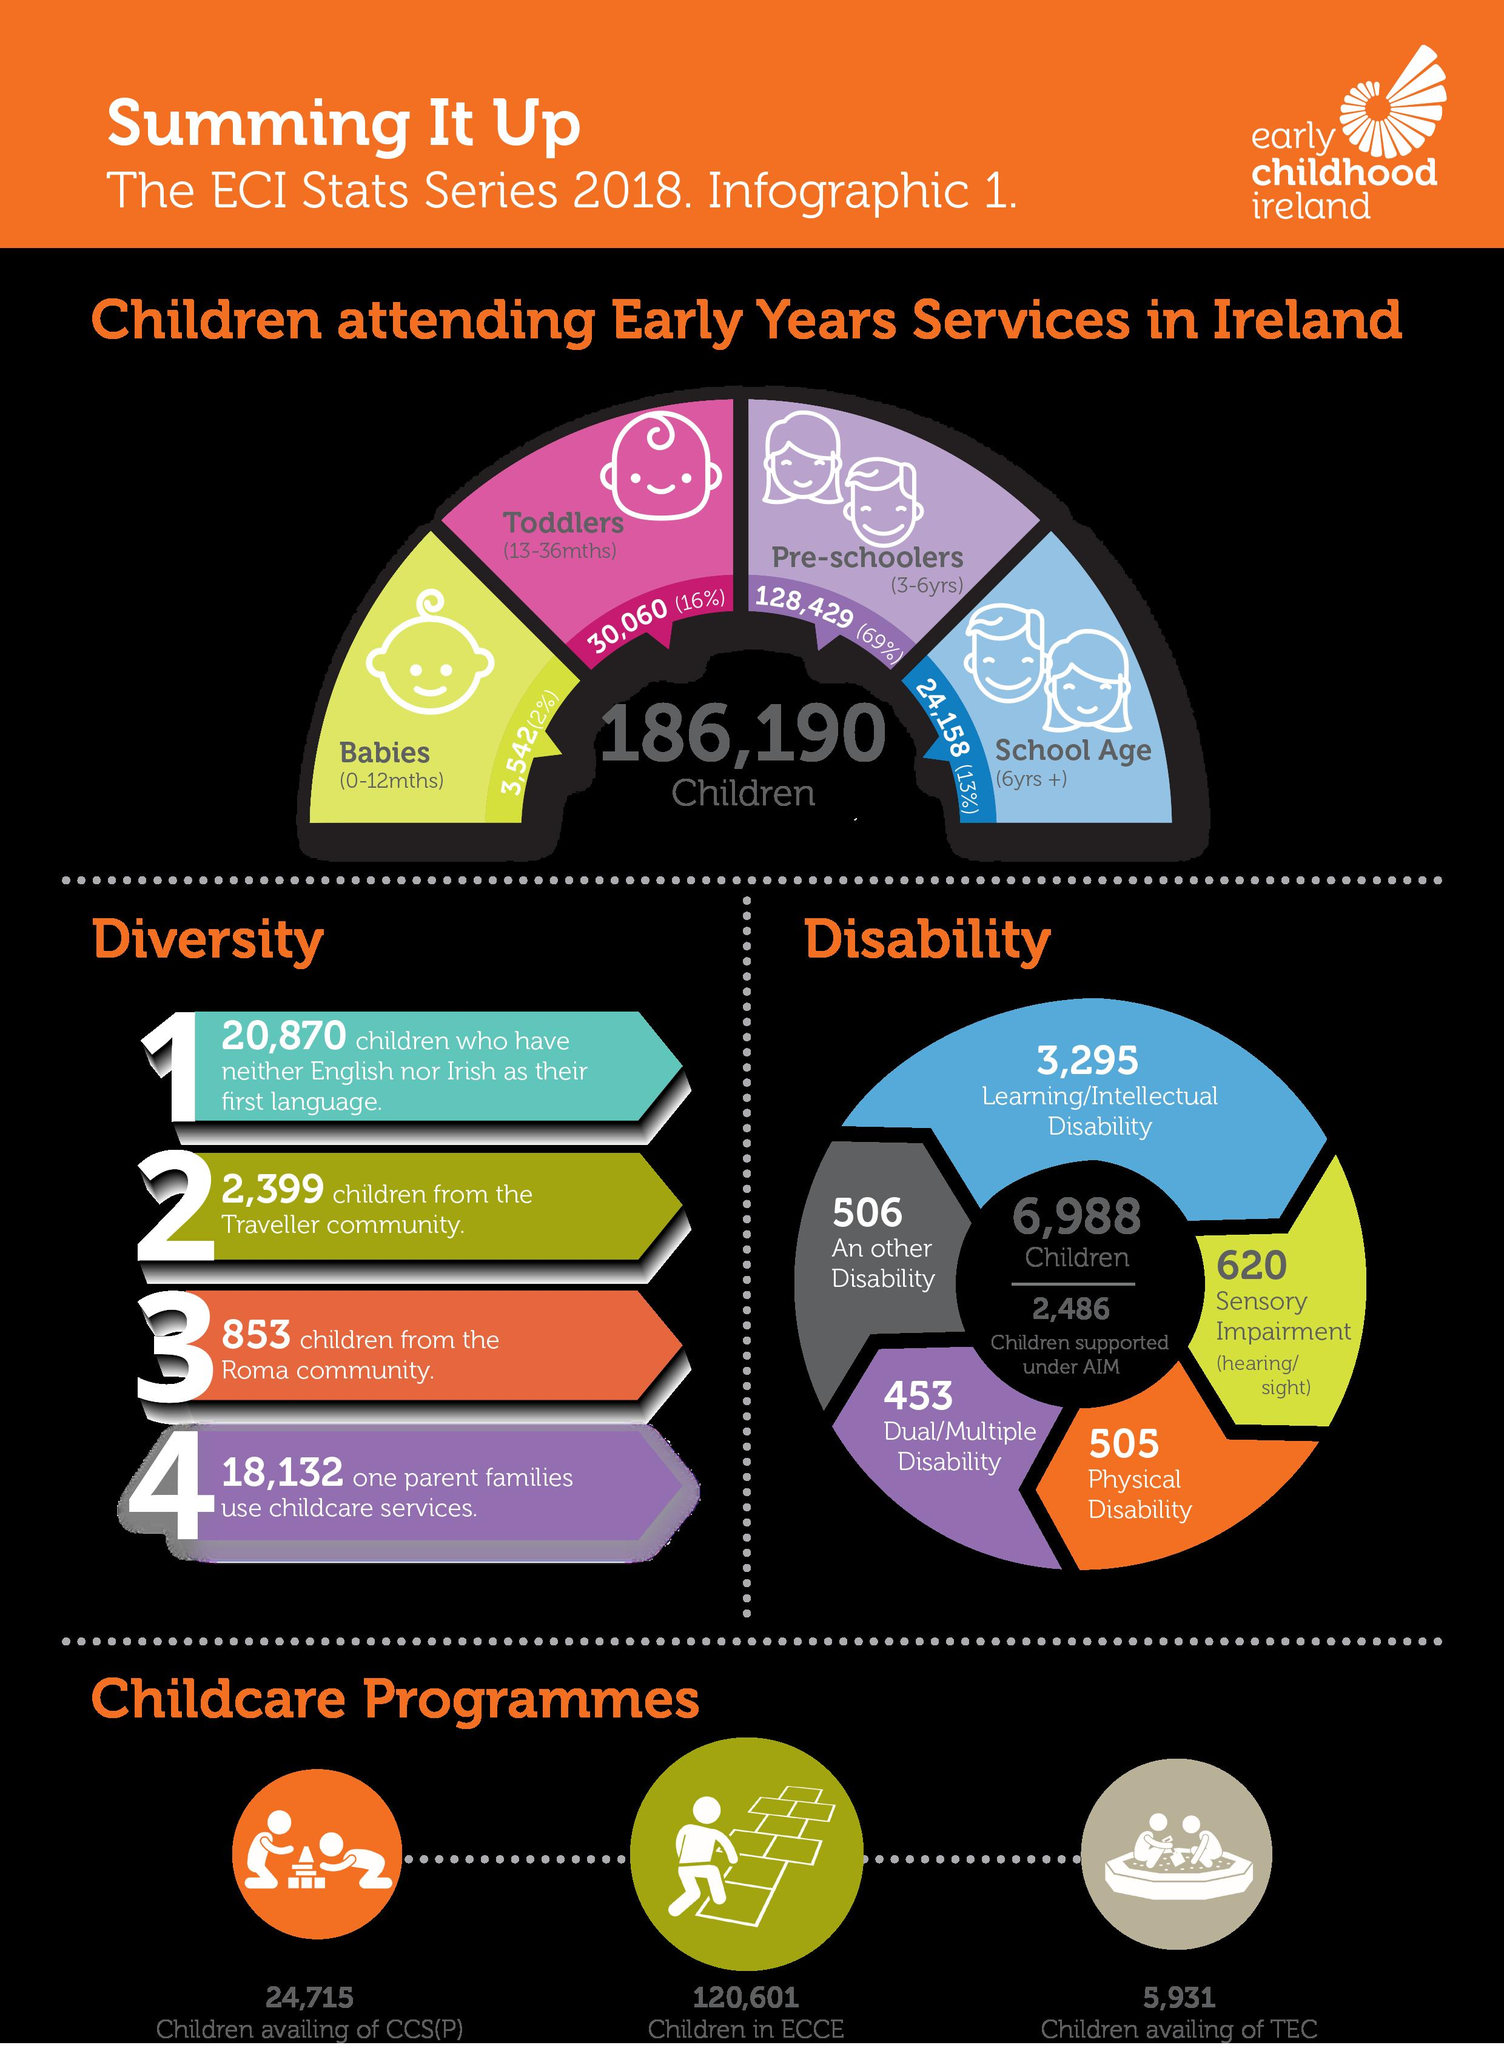Draw attention to some important aspects in this diagram. According to the ECI Stats Series 2018, 16% of toddlers aged 13-36 months in Ireland were attending early years services. According to the ECI Stats Series 2018, there are approximately 620 children in Ireland who have sensory impairment. According to the ECI Stats Series 2018, there were approximately 505 children in Ireland with physical disabilities. According to the ECI Stats Series 2018, 69% of preschoolers aged 3-6 years were attending early years services in Ireland. As per the ECI Stats Series 2018, there were 3,542 babies aged 0-12 months who were attending early years services in Ireland. 